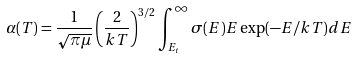<formula> <loc_0><loc_0><loc_500><loc_500>\alpha ( T ) = \frac { 1 } { \sqrt { \pi \mu } } \left ( \frac { 2 } { k T } \right ) ^ { 3 / 2 } \int _ { E _ { t } } ^ { \infty } \sigma ( E ) E \exp ( - E / k T ) d E</formula> 